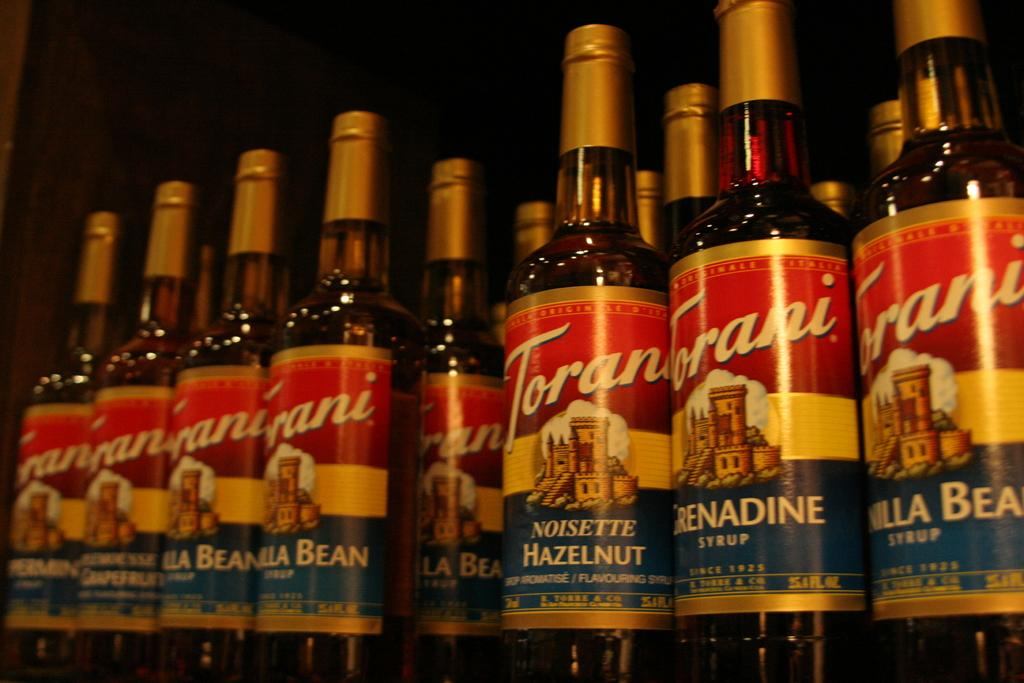<image>
Create a compact narrative representing the image presented. Several bottles of Torani syrup of different flavors. 